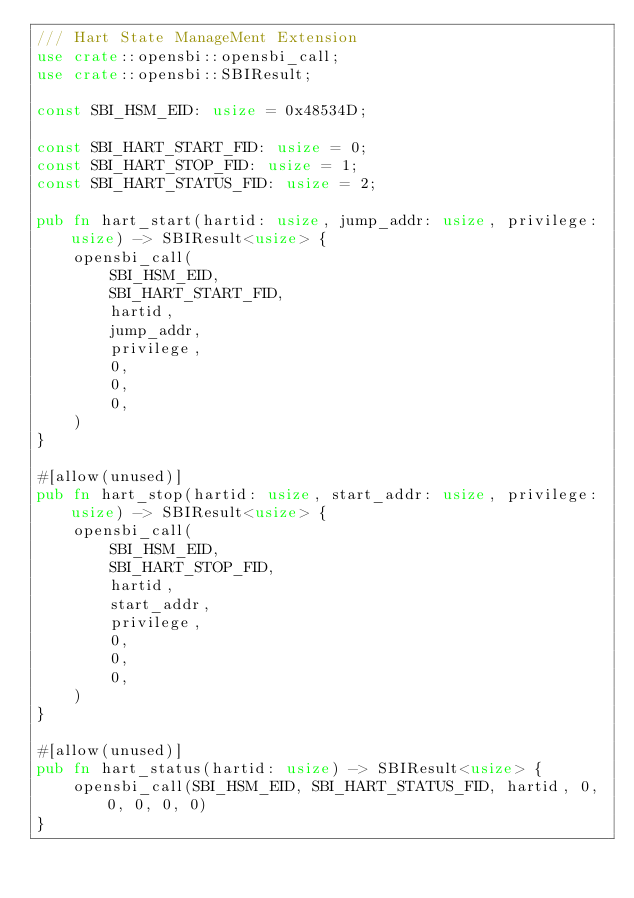Convert code to text. <code><loc_0><loc_0><loc_500><loc_500><_Rust_>/// Hart State ManageMent Extension
use crate::opensbi::opensbi_call;
use crate::opensbi::SBIResult;

const SBI_HSM_EID: usize = 0x48534D;

const SBI_HART_START_FID: usize = 0;
const SBI_HART_STOP_FID: usize = 1;
const SBI_HART_STATUS_FID: usize = 2;

pub fn hart_start(hartid: usize, jump_addr: usize, privilege: usize) -> SBIResult<usize> {
    opensbi_call(
        SBI_HSM_EID,
        SBI_HART_START_FID,
        hartid,
        jump_addr,
        privilege,
        0,
        0,
        0,
    )
}

#[allow(unused)]
pub fn hart_stop(hartid: usize, start_addr: usize, privilege: usize) -> SBIResult<usize> {
    opensbi_call(
        SBI_HSM_EID,
        SBI_HART_STOP_FID,
        hartid,
        start_addr,
        privilege,
        0,
        0,
        0,
    )
}

#[allow(unused)]
pub fn hart_status(hartid: usize) -> SBIResult<usize> {
    opensbi_call(SBI_HSM_EID, SBI_HART_STATUS_FID, hartid, 0, 0, 0, 0, 0)
}
</code> 